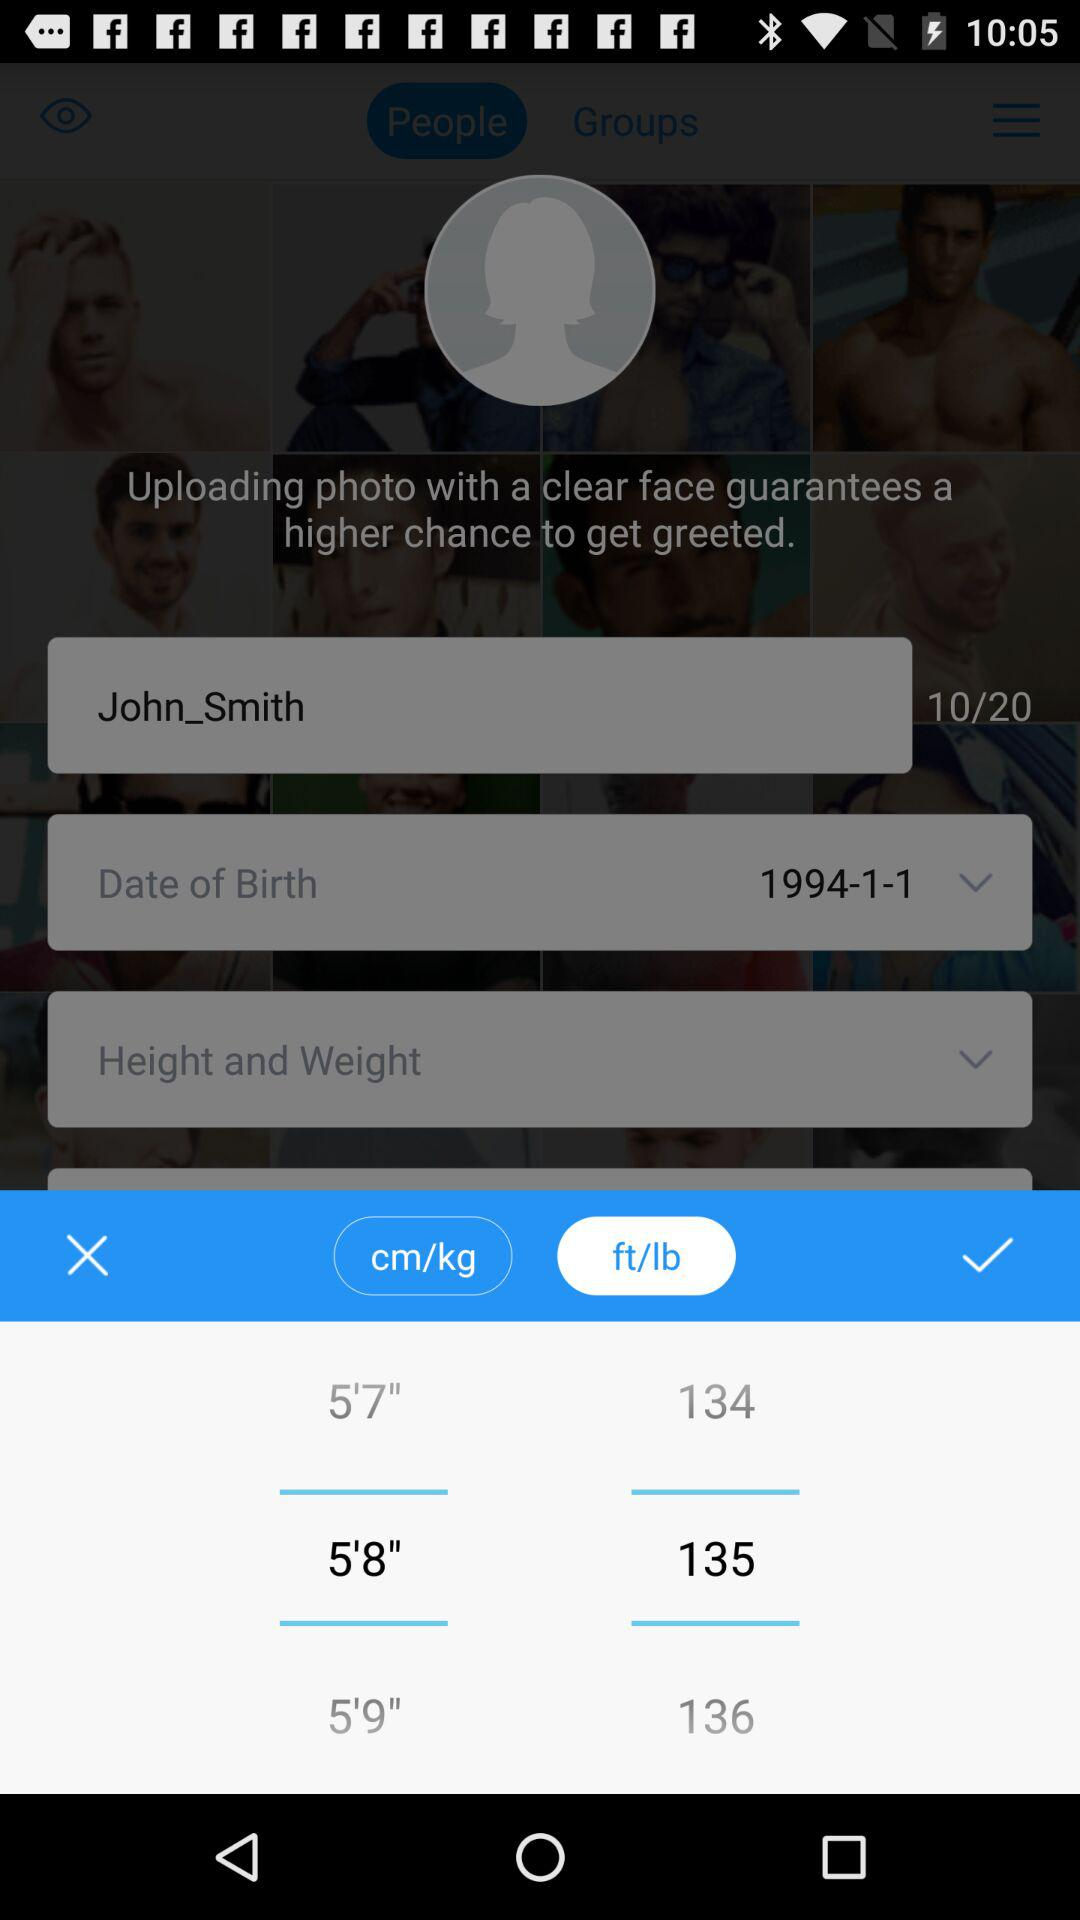Which gender is selected?
When the provided information is insufficient, respond with <no answer>. <no answer> 